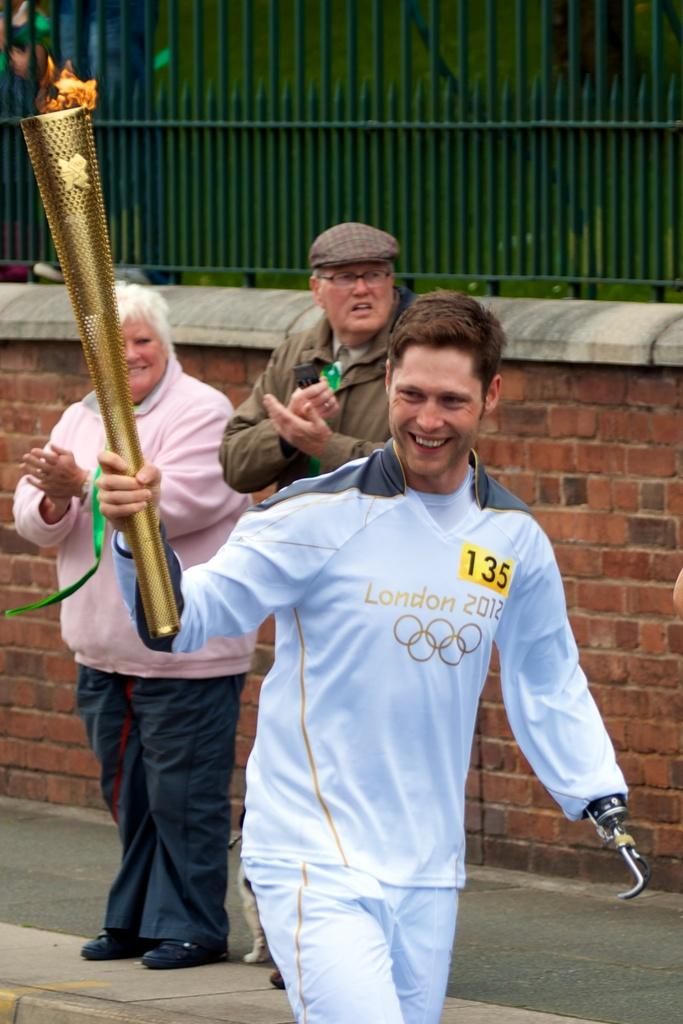Provide a one-sentence caption for the provided image. The person holding the torch is wearing the number 135. 